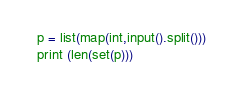Convert code to text. <code><loc_0><loc_0><loc_500><loc_500><_Python_>p = list(map(int,input().split()))
print (len(set(p)))</code> 